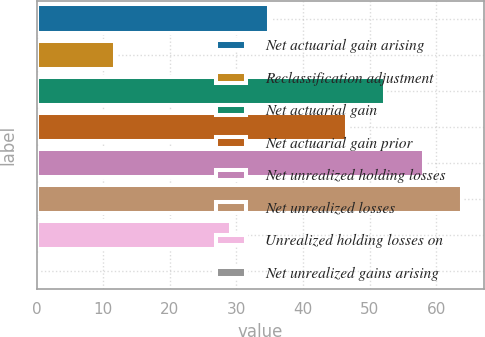Convert chart to OTSL. <chart><loc_0><loc_0><loc_500><loc_500><bar_chart><fcel>Net actuarial gain arising<fcel>Reclassification adjustment<fcel>Net actuarial gain<fcel>Net actuarial gain prior<fcel>Net unrealized holding losses<fcel>Net unrealized losses<fcel>Unrealized holding losses on<fcel>Net unrealized gains arising<nl><fcel>34.94<fcel>11.78<fcel>52.31<fcel>46.52<fcel>58.1<fcel>63.89<fcel>29.15<fcel>0.2<nl></chart> 